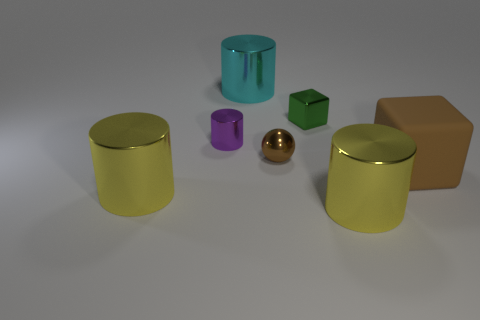What number of other things are there of the same size as the brown rubber thing? Including the brown cube, there are two objects that are of a similar size. The other is the purple cylindrical object. 